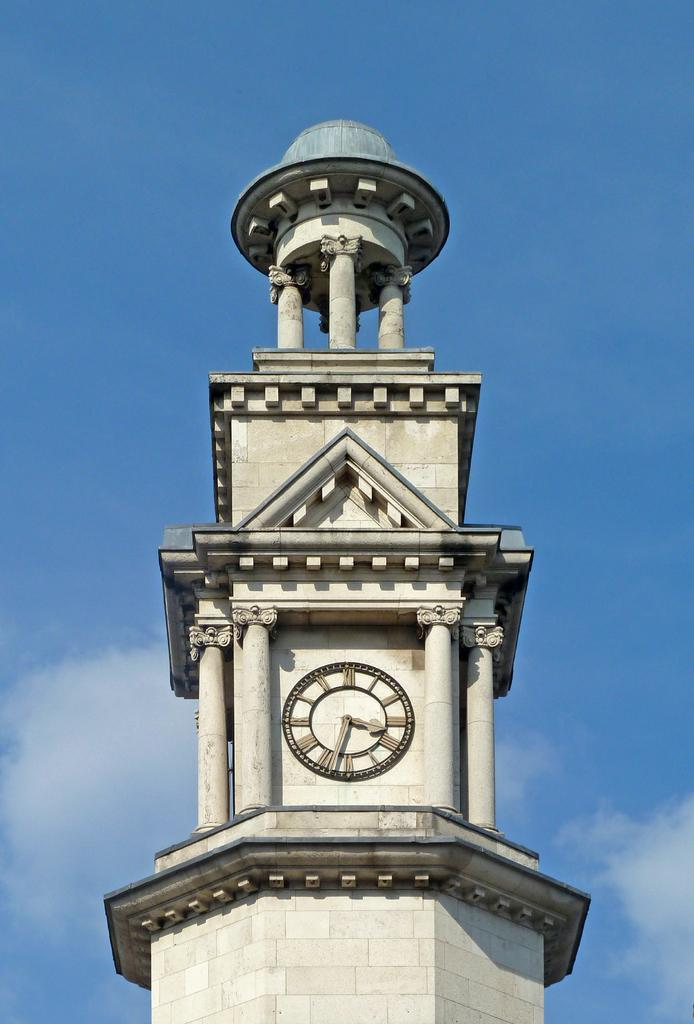What is the main structure in the picture? There is a clock tower in the picture. What can be seen in the sky in the picture? There are clouds visible in the sky. Can you see a yoke on the seashore in the picture? There is no yoke or seashore present in the picture; it features a clock tower and clouds in the sky. 